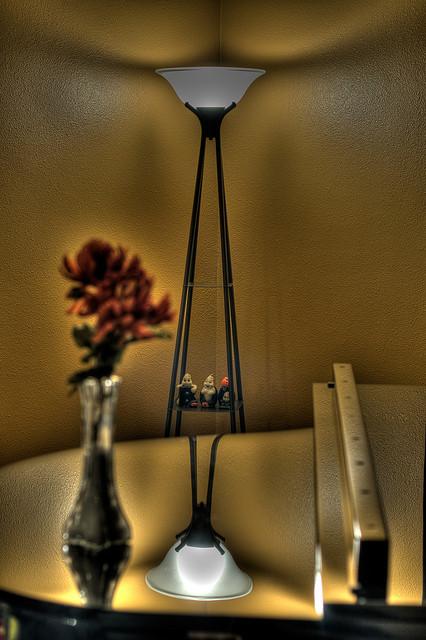Is the lamps reflection showing?
Quick response, please. Yes. What are those figurines?
Be succinct. Ghosts. What is shining on the wall?
Short answer required. Light. What musical instrument is in the picture?
Short answer required. Piano. 